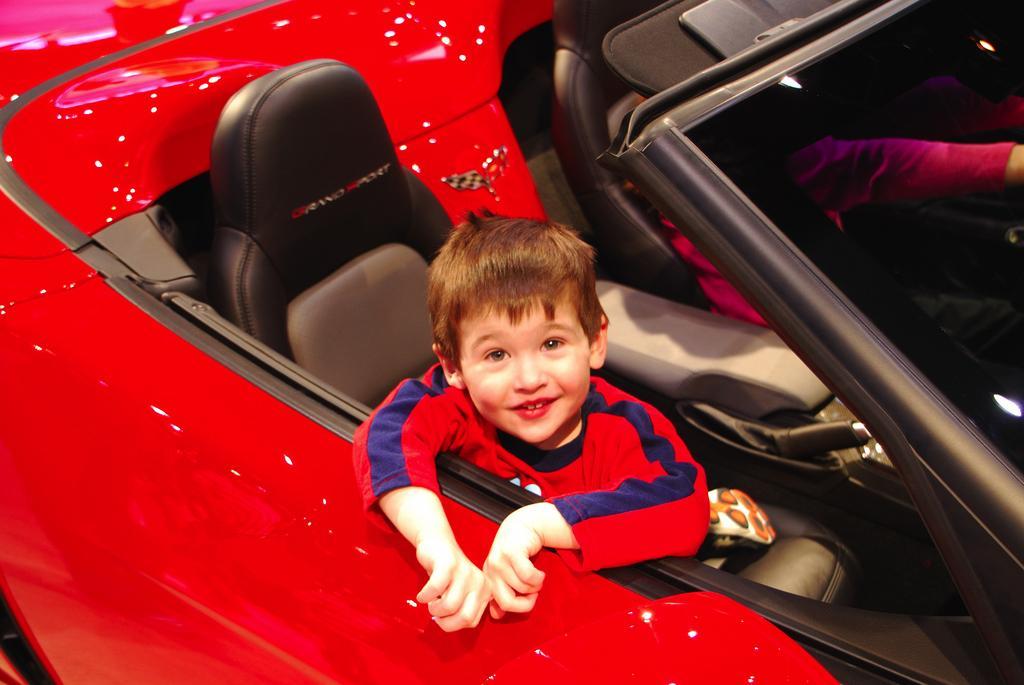Describe this image in one or two sentences. In this picture we can see a boy sitting on a seat and smiling and he is on a red color car and beside to him we can see a person. 